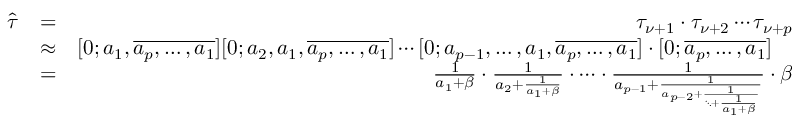Convert formula to latex. <formula><loc_0><loc_0><loc_500><loc_500>\begin{array} { r l r } { \hat { \tau } } & { = } & { \tau _ { \nu + 1 } \cdot \tau _ { \nu + 2 } \cdots \tau _ { \nu + p } } \\ & { \approx } & { [ 0 ; a _ { 1 } , \overline { { a _ { p } , \dots , a _ { 1 } } } ] [ 0 ; a _ { 2 } , a _ { 1 } , \overline { { a _ { p } , \dots , a _ { 1 } } } ] \cdots [ 0 ; a _ { p - 1 } , \dots , a _ { 1 } , \overline { { a _ { p } , \dots , a _ { 1 } } } ] \cdot [ 0 ; \overline { { a _ { p } , \dots , a _ { 1 } } } ] \quad } \\ & { = } & { \frac { 1 } { a _ { 1 } + \beta } \cdot \frac { 1 } { a _ { 2 } + \frac { 1 } { a _ { 1 } + \beta } } \cdot \cdots \cdot \frac { 1 } { a _ { p - 1 } + \frac { 1 } { a _ { p - 2 } + \frac { 1 } { \ddots + \frac { 1 } { a _ { 1 } + \beta } } } } \cdot \beta } \end{array}</formula> 